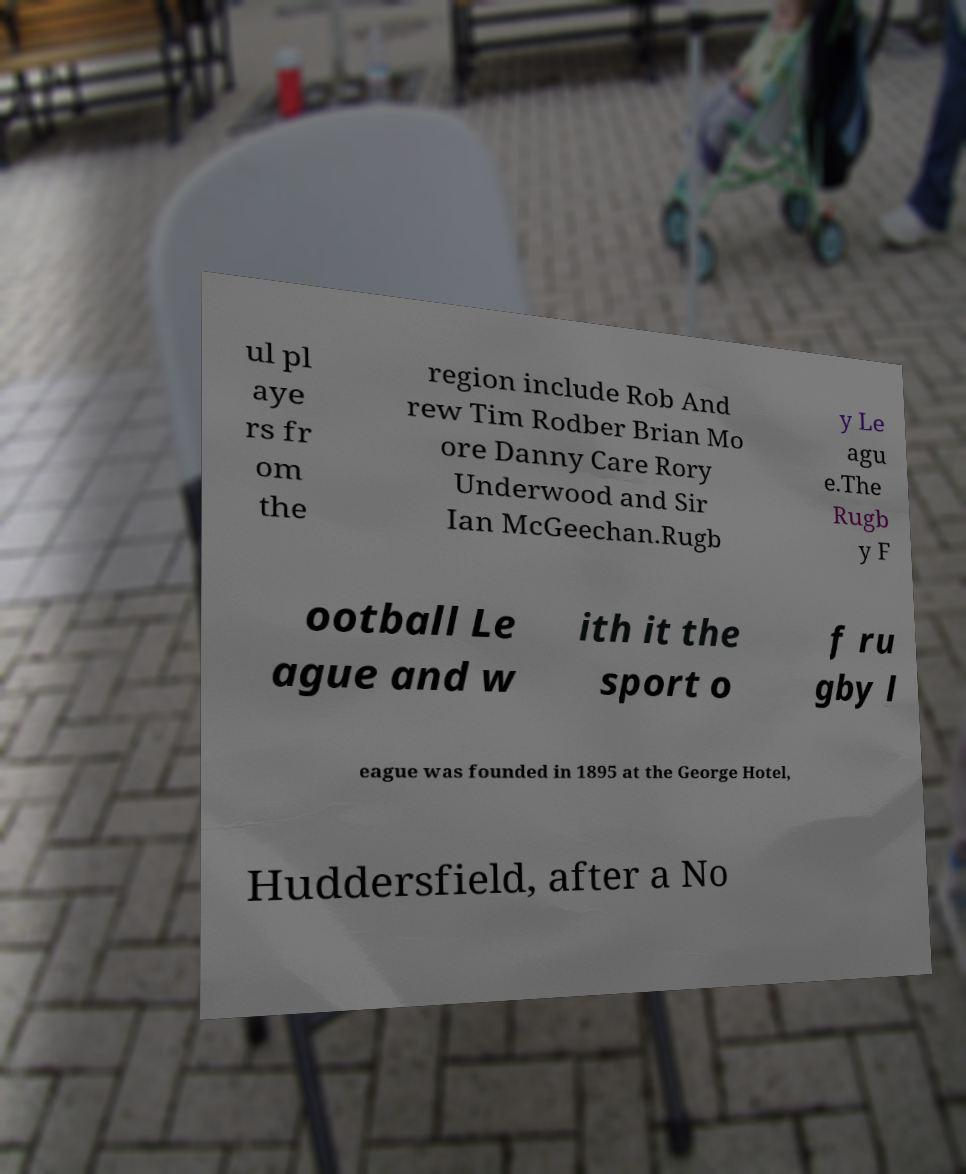For documentation purposes, I need the text within this image transcribed. Could you provide that? ul pl aye rs fr om the region include Rob And rew Tim Rodber Brian Mo ore Danny Care Rory Underwood and Sir Ian McGeechan.Rugb y Le agu e.The Rugb y F ootball Le ague and w ith it the sport o f ru gby l eague was founded in 1895 at the George Hotel, Huddersfield, after a No 